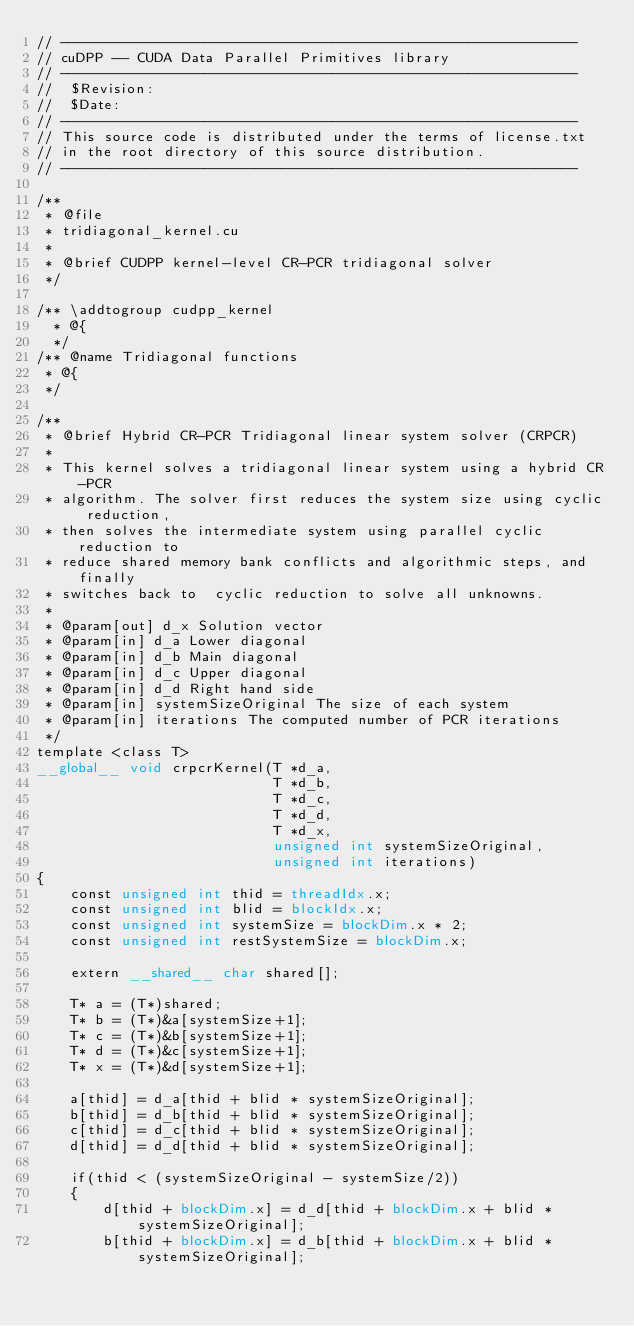<code> <loc_0><loc_0><loc_500><loc_500><_Cuda_>// -------------------------------------------------------------
// cuDPP -- CUDA Data Parallel Primitives library
// -------------------------------------------------------------
//  $Revision:
//  $Date:
// ------------------------------------------------------------- 
// This source code is distributed under the terms of license.txt 
// in the root directory of this source distribution.
// ------------------------------------------------------------- 

/**
 * @file
 * tridiagonal_kernel.cu
 *
 * @brief CUDPP kernel-level CR-PCR tridiagonal solver
 */

/** \addtogroup cudpp_kernel
  * @{
  */
/** @name Tridiagonal functions
 * @{
 */

/**
 * @brief Hybrid CR-PCR Tridiagonal linear system solver (CRPCR)
 *
 * This kernel solves a tridiagonal linear system using a hybrid CR-PCR 
 * algorithm. The solver first reduces the system size using cyclic reduction, 
 * then solves the intermediate system using parallel cyclic reduction to 
 * reduce shared memory bank conflicts and algorithmic steps, and finally 
 * switches back to  cyclic reduction to solve all unknowns.
 *
 * @param[out] d_x Solution vector
 * @param[in] d_a Lower diagonal
 * @param[in] d_b Main diagonal
 * @param[in] d_c Upper diagonal
 * @param[in] d_d Right hand side
 * @param[in] systemSizeOriginal The size of each system
 * @param[in] iterations The computed number of PCR iterations
 */
template <class T>
__global__ void crpcrKernel(T *d_a, 
                            T *d_b, 
                            T *d_c, 
                            T *d_d, 
                            T *d_x, 
                            unsigned int systemSizeOriginal,
                            unsigned int iterations)
{
    const unsigned int thid = threadIdx.x;
    const unsigned int blid = blockIdx.x;
    const unsigned int systemSize = blockDim.x * 2;
    const unsigned int restSystemSize = blockDim.x;
    
    extern __shared__ char shared[];

    T* a = (T*)shared;
    T* b = (T*)&a[systemSize+1];
    T* c = (T*)&b[systemSize+1];
    T* d = (T*)&c[systemSize+1];
    T* x = (T*)&d[systemSize+1];

    a[thid] = d_a[thid + blid * systemSizeOriginal];
    b[thid] = d_b[thid + blid * systemSizeOriginal];
    c[thid] = d_c[thid + blid * systemSizeOriginal];
    d[thid] = d_d[thid + blid * systemSizeOriginal];
    
    if(thid < (systemSizeOriginal - systemSize/2))
    {
        d[thid + blockDim.x] = d_d[thid + blockDim.x + blid * systemSizeOriginal];
        b[thid + blockDim.x] = d_b[thid + blockDim.x + blid * systemSizeOriginal];</code> 